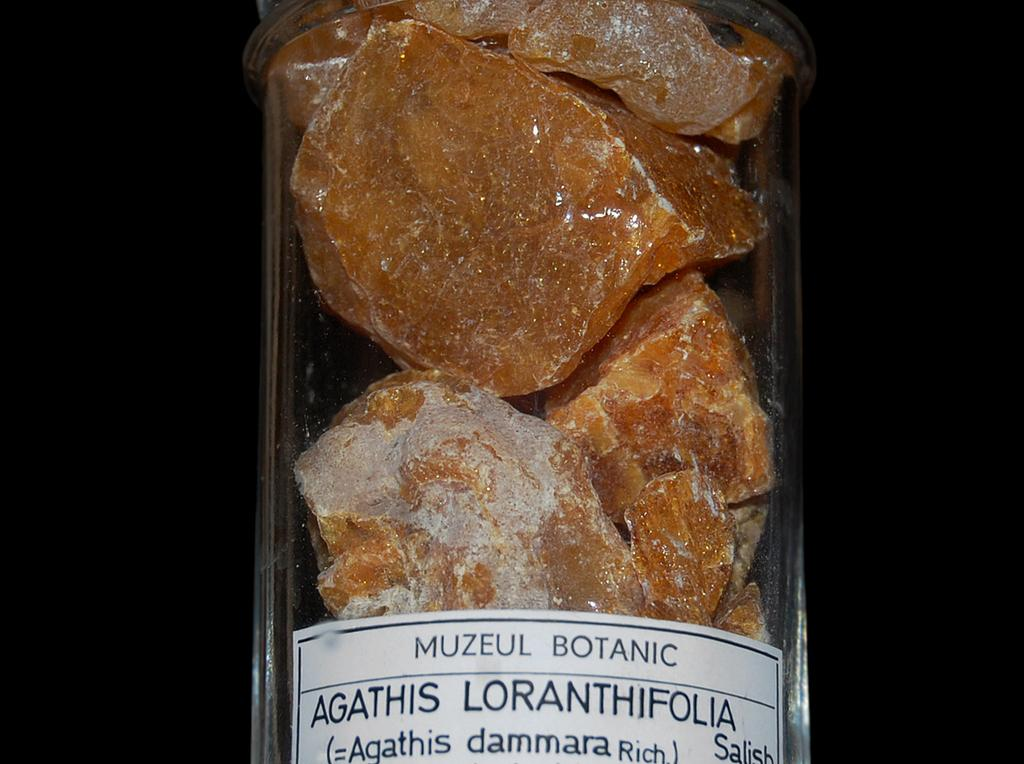What object can be seen in the image? There is a bottle in the image. What is inside the bottle? There are stones inside the bottle. Is there any writing on the bottle? Yes, there is text written on the bottle. What type of mask is visible inside the bottle? There is no mask present inside the bottle; it contains stones. How is the paste being used in the image? There is no paste present in the image. 